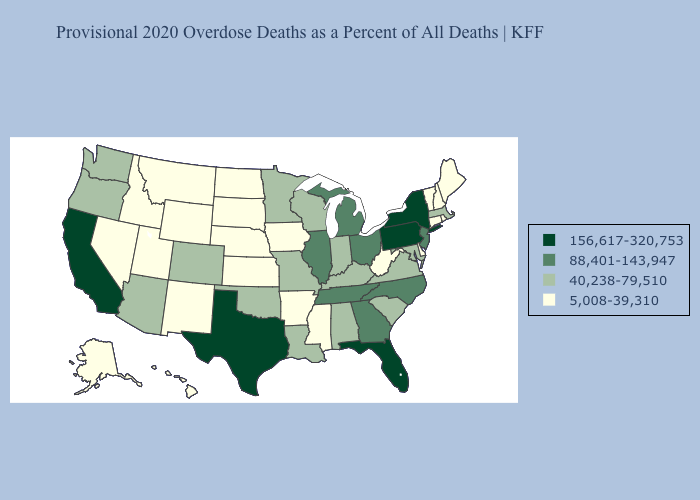What is the lowest value in the USA?
Answer briefly. 5,008-39,310. What is the highest value in the Northeast ?
Quick response, please. 156,617-320,753. Name the states that have a value in the range 88,401-143,947?
Quick response, please. Georgia, Illinois, Michigan, New Jersey, North Carolina, Ohio, Tennessee. What is the lowest value in the Northeast?
Concise answer only. 5,008-39,310. How many symbols are there in the legend?
Be succinct. 4. Which states have the lowest value in the USA?
Keep it brief. Alaska, Arkansas, Connecticut, Delaware, Hawaii, Idaho, Iowa, Kansas, Maine, Mississippi, Montana, Nebraska, Nevada, New Hampshire, New Mexico, North Dakota, Rhode Island, South Dakota, Utah, Vermont, West Virginia, Wyoming. Which states have the lowest value in the USA?
Be succinct. Alaska, Arkansas, Connecticut, Delaware, Hawaii, Idaho, Iowa, Kansas, Maine, Mississippi, Montana, Nebraska, Nevada, New Hampshire, New Mexico, North Dakota, Rhode Island, South Dakota, Utah, Vermont, West Virginia, Wyoming. What is the value of Mississippi?
Quick response, please. 5,008-39,310. What is the value of Wyoming?
Keep it brief. 5,008-39,310. What is the lowest value in the USA?
Short answer required. 5,008-39,310. Which states hav the highest value in the West?
Answer briefly. California. Does the map have missing data?
Be succinct. No. Among the states that border Texas , which have the highest value?
Quick response, please. Louisiana, Oklahoma. Which states hav the highest value in the South?
Concise answer only. Florida, Texas. Which states have the lowest value in the USA?
Concise answer only. Alaska, Arkansas, Connecticut, Delaware, Hawaii, Idaho, Iowa, Kansas, Maine, Mississippi, Montana, Nebraska, Nevada, New Hampshire, New Mexico, North Dakota, Rhode Island, South Dakota, Utah, Vermont, West Virginia, Wyoming. 